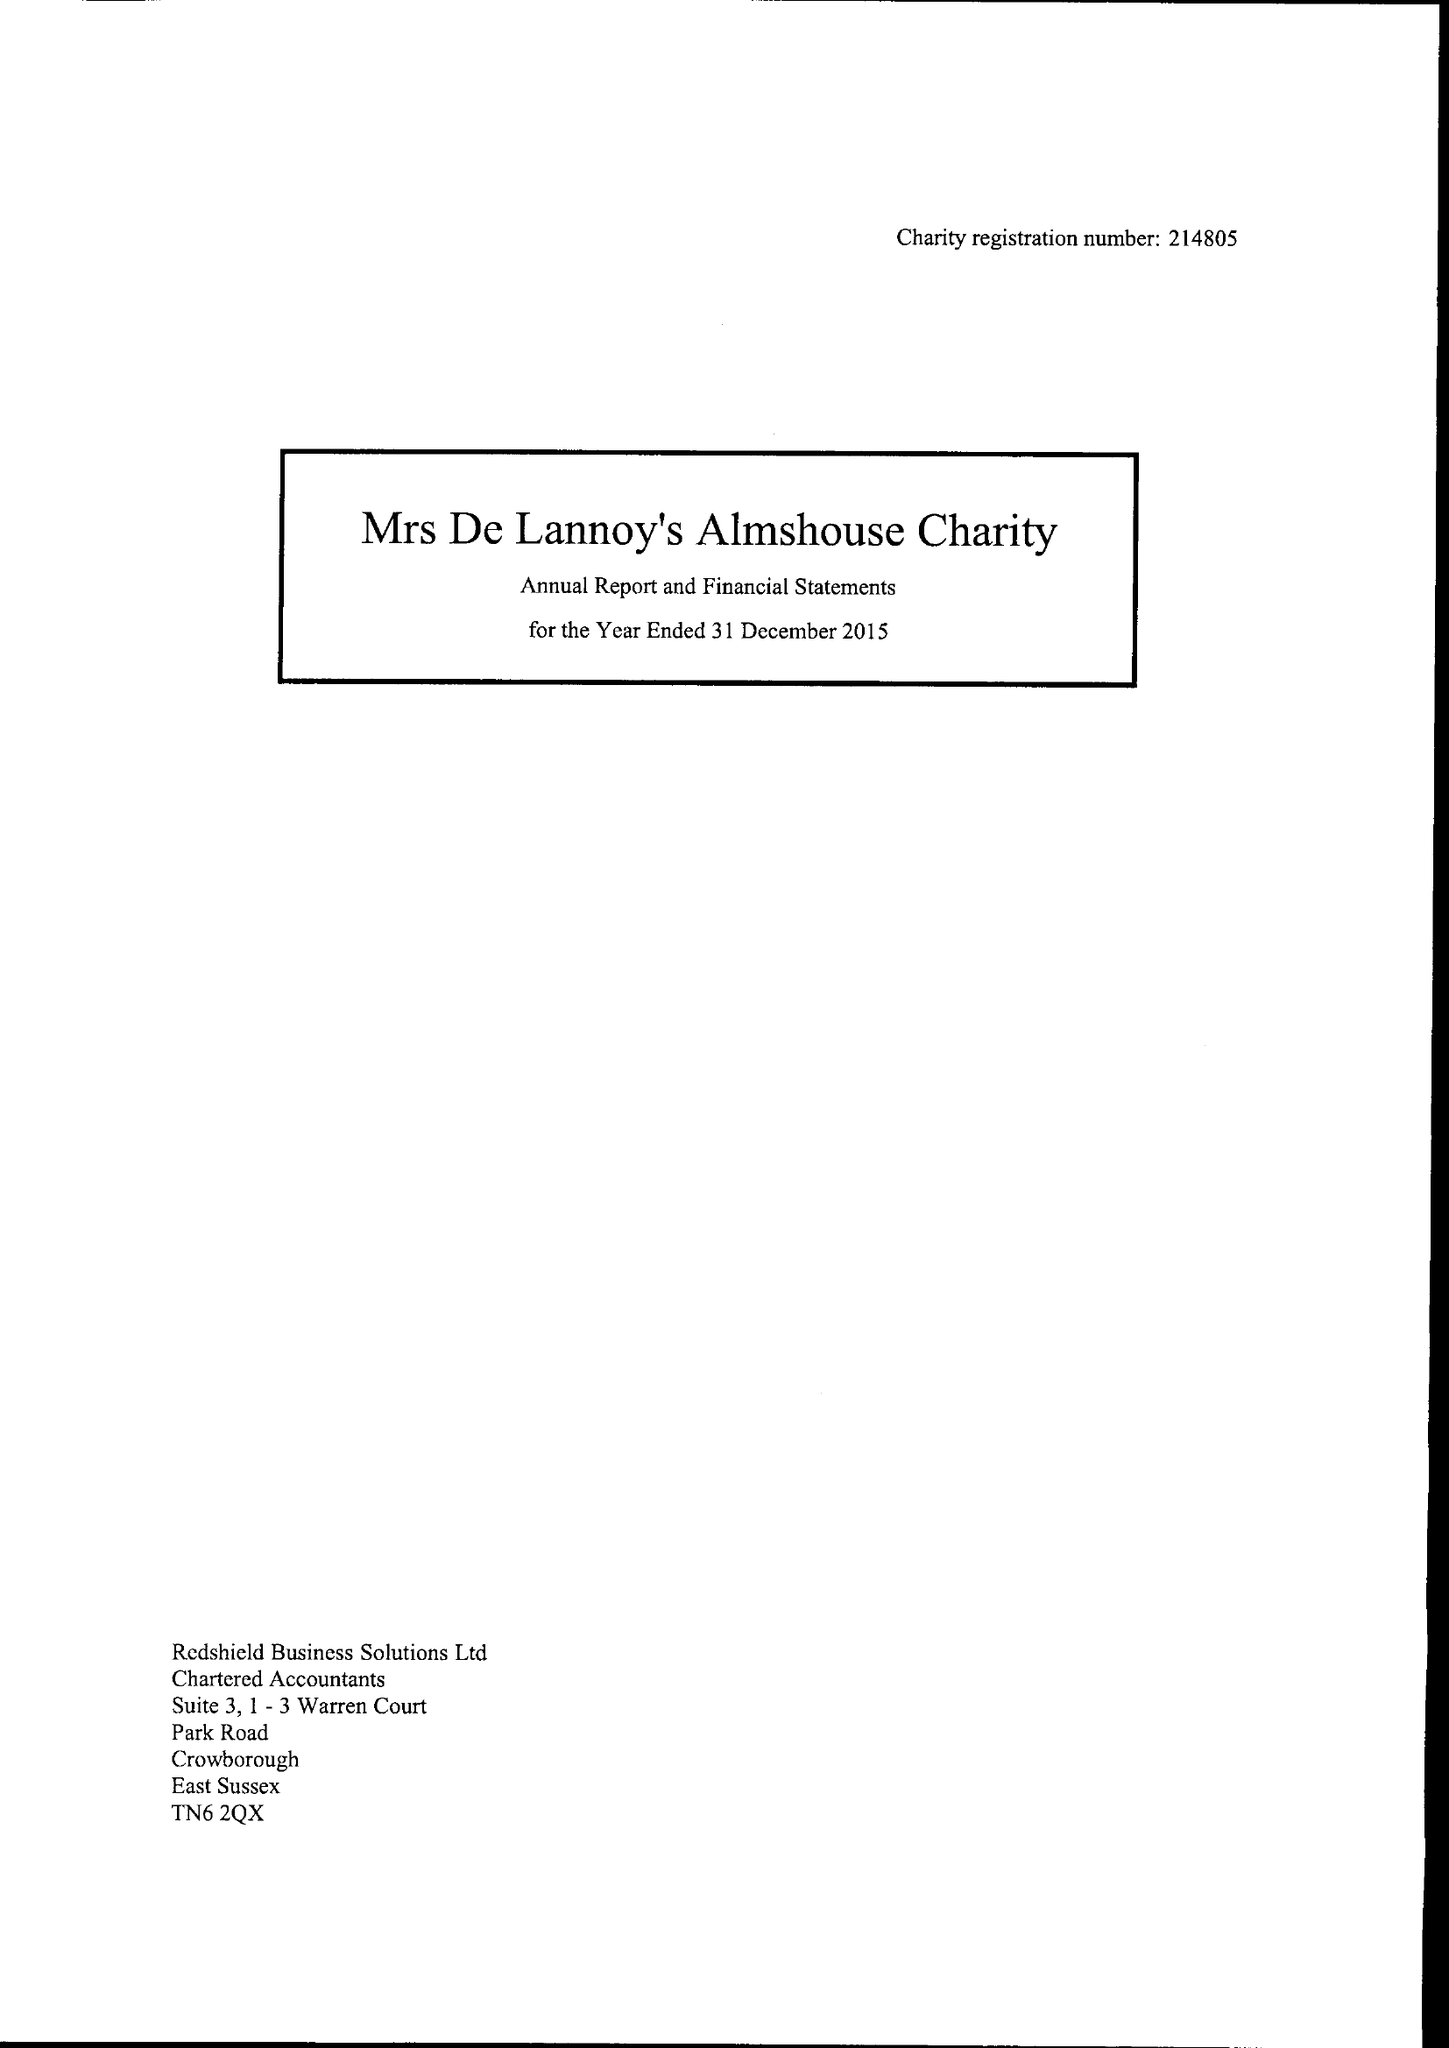What is the value for the address__post_town?
Answer the question using a single word or phrase. CROWBOROUGH 